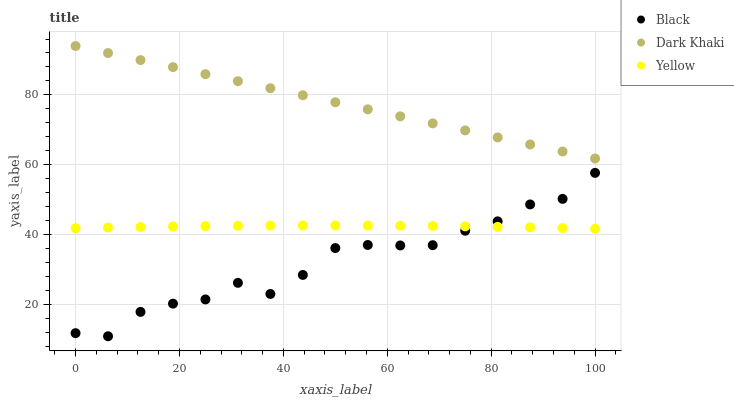Does Black have the minimum area under the curve?
Answer yes or no. Yes. Does Dark Khaki have the maximum area under the curve?
Answer yes or no. Yes. Does Yellow have the minimum area under the curve?
Answer yes or no. No. Does Yellow have the maximum area under the curve?
Answer yes or no. No. Is Dark Khaki the smoothest?
Answer yes or no. Yes. Is Black the roughest?
Answer yes or no. Yes. Is Yellow the smoothest?
Answer yes or no. No. Is Yellow the roughest?
Answer yes or no. No. Does Black have the lowest value?
Answer yes or no. Yes. Does Yellow have the lowest value?
Answer yes or no. No. Does Dark Khaki have the highest value?
Answer yes or no. Yes. Does Black have the highest value?
Answer yes or no. No. Is Black less than Dark Khaki?
Answer yes or no. Yes. Is Dark Khaki greater than Black?
Answer yes or no. Yes. Does Black intersect Yellow?
Answer yes or no. Yes. Is Black less than Yellow?
Answer yes or no. No. Is Black greater than Yellow?
Answer yes or no. No. Does Black intersect Dark Khaki?
Answer yes or no. No. 